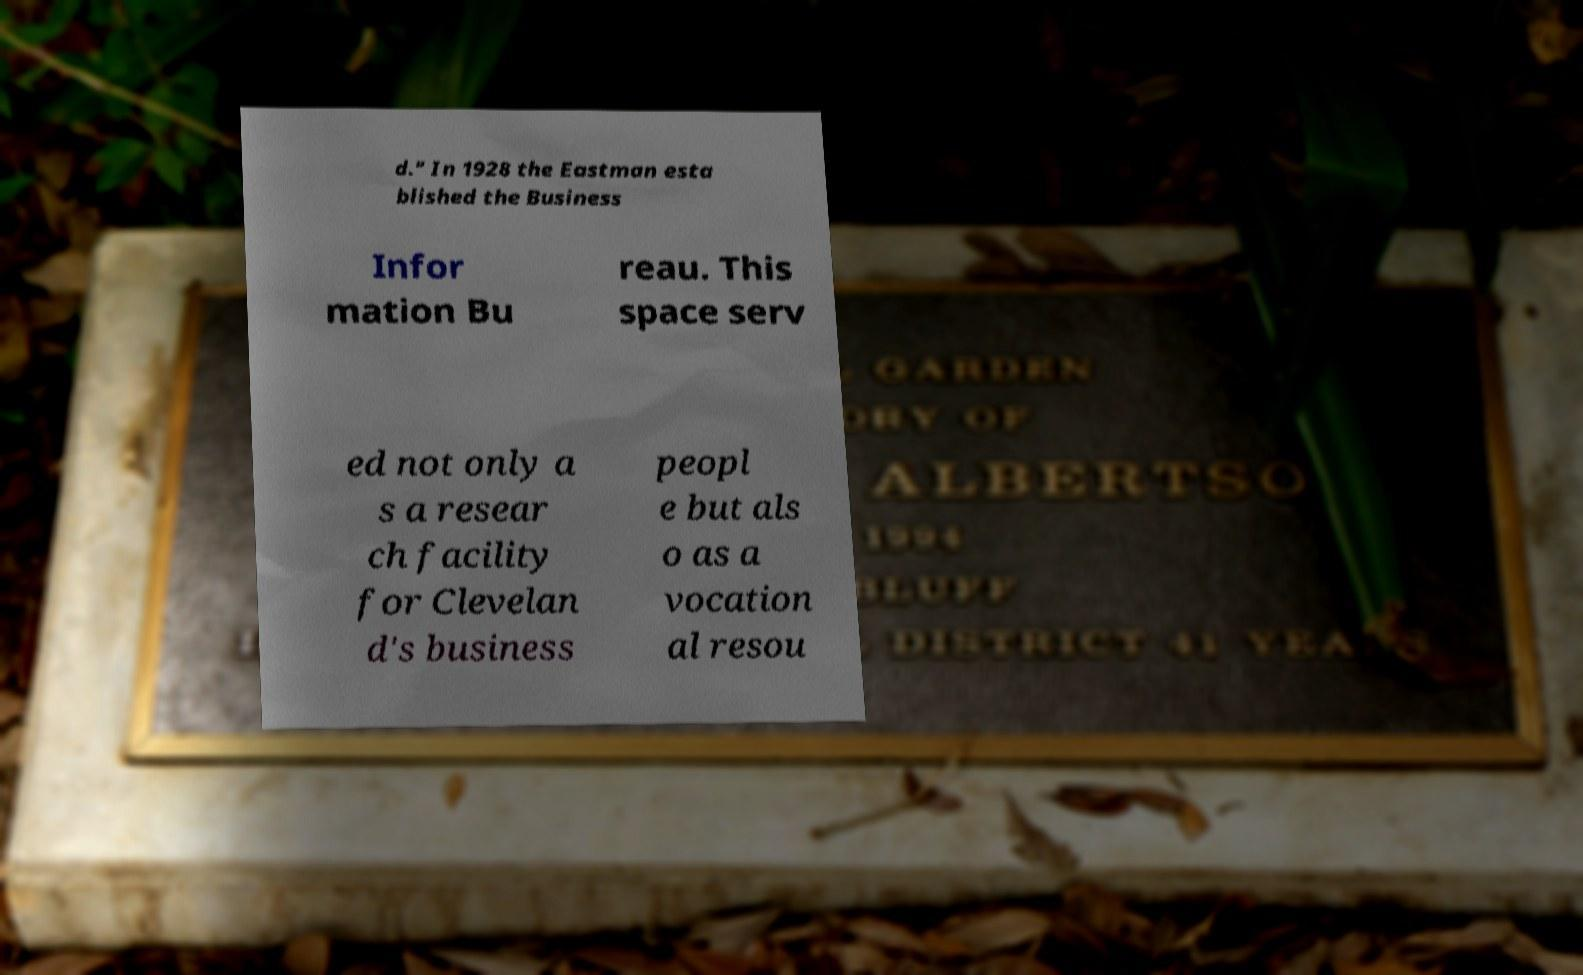I need the written content from this picture converted into text. Can you do that? d." In 1928 the Eastman esta blished the Business Infor mation Bu reau. This space serv ed not only a s a resear ch facility for Clevelan d's business peopl e but als o as a vocation al resou 